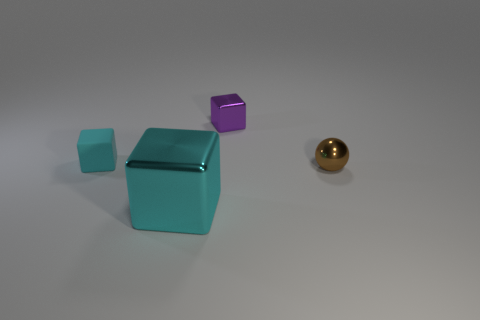Can you describe the lighting and shadows present in this scene? The lighting in the image appears to be diffused, casting soft shadows that gently outline the objects on the surface. The direction of the light seems to be from the upper left side, as evidenced by the shadows primarily extending towards the lower right. The lighting accentuates the objects' forms and provides a calm, muted ambience. 